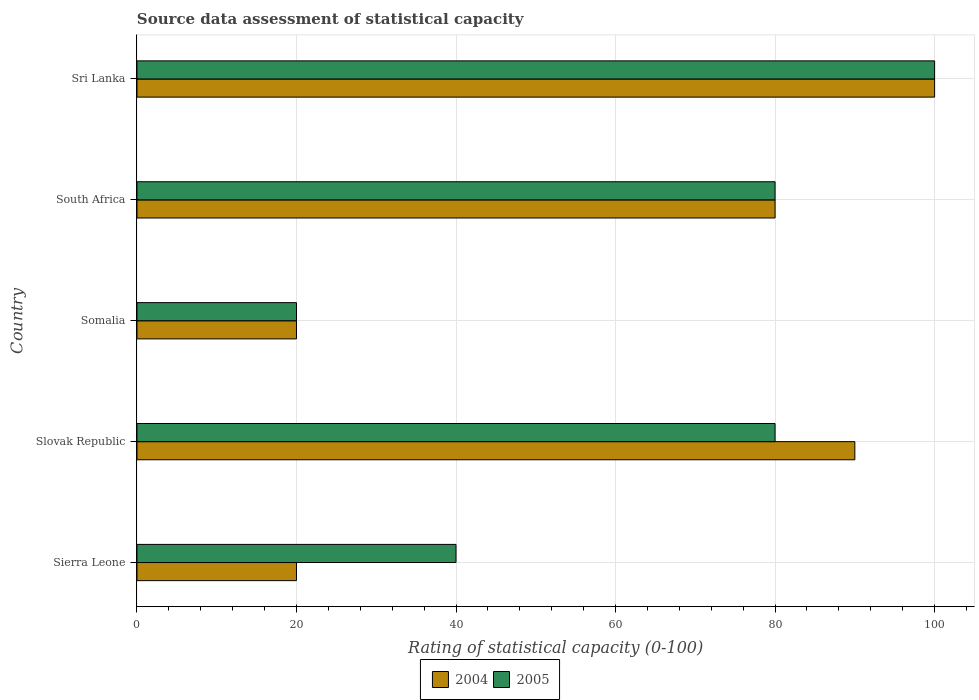How many different coloured bars are there?
Ensure brevity in your answer.  2. Are the number of bars on each tick of the Y-axis equal?
Ensure brevity in your answer.  Yes. How many bars are there on the 2nd tick from the bottom?
Your answer should be compact. 2. What is the label of the 1st group of bars from the top?
Offer a very short reply. Sri Lanka. In how many cases, is the number of bars for a given country not equal to the number of legend labels?
Ensure brevity in your answer.  0. What is the rating of statistical capacity in 2004 in Sierra Leone?
Give a very brief answer. 20. Across all countries, what is the maximum rating of statistical capacity in 2004?
Provide a short and direct response. 100. In which country was the rating of statistical capacity in 2005 maximum?
Your answer should be compact. Sri Lanka. In which country was the rating of statistical capacity in 2004 minimum?
Ensure brevity in your answer.  Sierra Leone. What is the total rating of statistical capacity in 2004 in the graph?
Ensure brevity in your answer.  310. What is the difference between the rating of statistical capacity in 2005 in South Africa and the rating of statistical capacity in 2004 in Slovak Republic?
Provide a succinct answer. -10. What is the ratio of the rating of statistical capacity in 2005 in Slovak Republic to that in South Africa?
Provide a succinct answer. 1. In how many countries, is the rating of statistical capacity in 2005 greater than the average rating of statistical capacity in 2005 taken over all countries?
Keep it short and to the point. 3. Is the sum of the rating of statistical capacity in 2004 in Sierra Leone and Slovak Republic greater than the maximum rating of statistical capacity in 2005 across all countries?
Keep it short and to the point. Yes. What does the 1st bar from the top in Slovak Republic represents?
Ensure brevity in your answer.  2005. How many countries are there in the graph?
Offer a very short reply. 5. What is the difference between two consecutive major ticks on the X-axis?
Ensure brevity in your answer.  20. Does the graph contain any zero values?
Offer a very short reply. No. Does the graph contain grids?
Provide a short and direct response. Yes. How many legend labels are there?
Provide a succinct answer. 2. What is the title of the graph?
Offer a terse response. Source data assessment of statistical capacity. What is the label or title of the X-axis?
Your response must be concise. Rating of statistical capacity (0-100). What is the label or title of the Y-axis?
Your answer should be compact. Country. What is the Rating of statistical capacity (0-100) in 2004 in Slovak Republic?
Provide a short and direct response. 90. What is the Rating of statistical capacity (0-100) of 2004 in Somalia?
Provide a succinct answer. 20. What is the Rating of statistical capacity (0-100) of 2004 in South Africa?
Provide a succinct answer. 80. What is the Rating of statistical capacity (0-100) of 2004 in Sri Lanka?
Your response must be concise. 100. Across all countries, what is the maximum Rating of statistical capacity (0-100) in 2004?
Your answer should be very brief. 100. Across all countries, what is the maximum Rating of statistical capacity (0-100) in 2005?
Ensure brevity in your answer.  100. Across all countries, what is the minimum Rating of statistical capacity (0-100) in 2004?
Offer a terse response. 20. What is the total Rating of statistical capacity (0-100) of 2004 in the graph?
Your answer should be compact. 310. What is the total Rating of statistical capacity (0-100) in 2005 in the graph?
Your answer should be compact. 320. What is the difference between the Rating of statistical capacity (0-100) of 2004 in Sierra Leone and that in Slovak Republic?
Your response must be concise. -70. What is the difference between the Rating of statistical capacity (0-100) in 2005 in Sierra Leone and that in Slovak Republic?
Give a very brief answer. -40. What is the difference between the Rating of statistical capacity (0-100) of 2004 in Sierra Leone and that in South Africa?
Keep it short and to the point. -60. What is the difference between the Rating of statistical capacity (0-100) of 2004 in Sierra Leone and that in Sri Lanka?
Give a very brief answer. -80. What is the difference between the Rating of statistical capacity (0-100) in 2005 in Sierra Leone and that in Sri Lanka?
Make the answer very short. -60. What is the difference between the Rating of statistical capacity (0-100) in 2004 in Slovak Republic and that in Somalia?
Ensure brevity in your answer.  70. What is the difference between the Rating of statistical capacity (0-100) of 2004 in Slovak Republic and that in Sri Lanka?
Offer a terse response. -10. What is the difference between the Rating of statistical capacity (0-100) in 2005 in Slovak Republic and that in Sri Lanka?
Offer a very short reply. -20. What is the difference between the Rating of statistical capacity (0-100) of 2004 in Somalia and that in South Africa?
Give a very brief answer. -60. What is the difference between the Rating of statistical capacity (0-100) of 2005 in Somalia and that in South Africa?
Offer a very short reply. -60. What is the difference between the Rating of statistical capacity (0-100) of 2004 in Somalia and that in Sri Lanka?
Make the answer very short. -80. What is the difference between the Rating of statistical capacity (0-100) of 2005 in Somalia and that in Sri Lanka?
Ensure brevity in your answer.  -80. What is the difference between the Rating of statistical capacity (0-100) of 2004 in Sierra Leone and the Rating of statistical capacity (0-100) of 2005 in Slovak Republic?
Your answer should be very brief. -60. What is the difference between the Rating of statistical capacity (0-100) of 2004 in Sierra Leone and the Rating of statistical capacity (0-100) of 2005 in Somalia?
Ensure brevity in your answer.  0. What is the difference between the Rating of statistical capacity (0-100) of 2004 in Sierra Leone and the Rating of statistical capacity (0-100) of 2005 in South Africa?
Your answer should be compact. -60. What is the difference between the Rating of statistical capacity (0-100) of 2004 in Sierra Leone and the Rating of statistical capacity (0-100) of 2005 in Sri Lanka?
Your answer should be compact. -80. What is the difference between the Rating of statistical capacity (0-100) of 2004 in Slovak Republic and the Rating of statistical capacity (0-100) of 2005 in South Africa?
Provide a short and direct response. 10. What is the difference between the Rating of statistical capacity (0-100) of 2004 in Somalia and the Rating of statistical capacity (0-100) of 2005 in South Africa?
Offer a very short reply. -60. What is the difference between the Rating of statistical capacity (0-100) of 2004 in Somalia and the Rating of statistical capacity (0-100) of 2005 in Sri Lanka?
Your response must be concise. -80. What is the difference between the Rating of statistical capacity (0-100) in 2004 in South Africa and the Rating of statistical capacity (0-100) in 2005 in Sri Lanka?
Provide a short and direct response. -20. What is the average Rating of statistical capacity (0-100) of 2005 per country?
Your answer should be very brief. 64. What is the difference between the Rating of statistical capacity (0-100) of 2004 and Rating of statistical capacity (0-100) of 2005 in South Africa?
Ensure brevity in your answer.  0. What is the ratio of the Rating of statistical capacity (0-100) in 2004 in Sierra Leone to that in Slovak Republic?
Provide a succinct answer. 0.22. What is the ratio of the Rating of statistical capacity (0-100) in 2004 in Sierra Leone to that in Somalia?
Keep it short and to the point. 1. What is the ratio of the Rating of statistical capacity (0-100) of 2005 in Sierra Leone to that in Somalia?
Offer a terse response. 2. What is the ratio of the Rating of statistical capacity (0-100) in 2004 in Sierra Leone to that in South Africa?
Offer a very short reply. 0.25. What is the ratio of the Rating of statistical capacity (0-100) of 2005 in Sierra Leone to that in South Africa?
Your response must be concise. 0.5. What is the ratio of the Rating of statistical capacity (0-100) of 2004 in Sierra Leone to that in Sri Lanka?
Offer a very short reply. 0.2. What is the ratio of the Rating of statistical capacity (0-100) in 2005 in Slovak Republic to that in Somalia?
Offer a terse response. 4. What is the ratio of the Rating of statistical capacity (0-100) of 2005 in Slovak Republic to that in Sri Lanka?
Keep it short and to the point. 0.8. What is the ratio of the Rating of statistical capacity (0-100) of 2004 in Somalia to that in South Africa?
Make the answer very short. 0.25. What is the ratio of the Rating of statistical capacity (0-100) in 2005 in Somalia to that in South Africa?
Your answer should be compact. 0.25. What is the ratio of the Rating of statistical capacity (0-100) of 2004 in Somalia to that in Sri Lanka?
Keep it short and to the point. 0.2. What is the ratio of the Rating of statistical capacity (0-100) in 2005 in South Africa to that in Sri Lanka?
Your answer should be very brief. 0.8. What is the difference between the highest and the second highest Rating of statistical capacity (0-100) in 2004?
Make the answer very short. 10. What is the difference between the highest and the second highest Rating of statistical capacity (0-100) in 2005?
Your response must be concise. 20. What is the difference between the highest and the lowest Rating of statistical capacity (0-100) in 2005?
Ensure brevity in your answer.  80. 